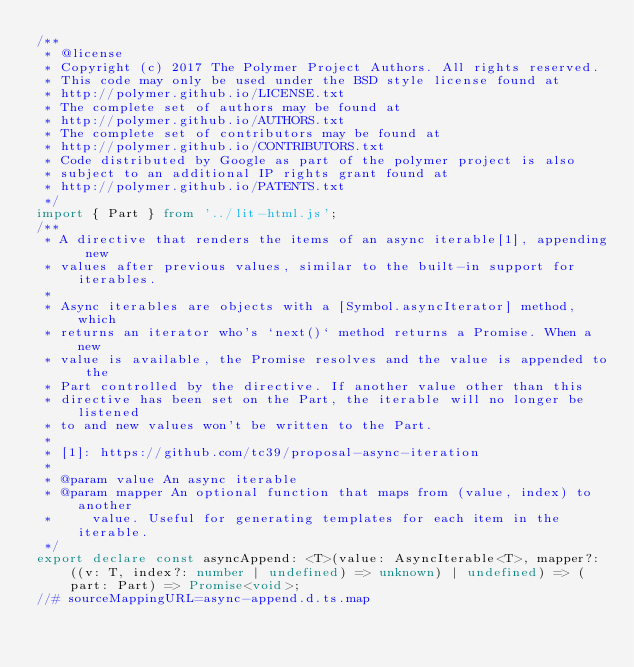<code> <loc_0><loc_0><loc_500><loc_500><_TypeScript_>/**
 * @license
 * Copyright (c) 2017 The Polymer Project Authors. All rights reserved.
 * This code may only be used under the BSD style license found at
 * http://polymer.github.io/LICENSE.txt
 * The complete set of authors may be found at
 * http://polymer.github.io/AUTHORS.txt
 * The complete set of contributors may be found at
 * http://polymer.github.io/CONTRIBUTORS.txt
 * Code distributed by Google as part of the polymer project is also
 * subject to an additional IP rights grant found at
 * http://polymer.github.io/PATENTS.txt
 */
import { Part } from '../lit-html.js';
/**
 * A directive that renders the items of an async iterable[1], appending new
 * values after previous values, similar to the built-in support for iterables.
 *
 * Async iterables are objects with a [Symbol.asyncIterator] method, which
 * returns an iterator who's `next()` method returns a Promise. When a new
 * value is available, the Promise resolves and the value is appended to the
 * Part controlled by the directive. If another value other than this
 * directive has been set on the Part, the iterable will no longer be listened
 * to and new values won't be written to the Part.
 *
 * [1]: https://github.com/tc39/proposal-async-iteration
 *
 * @param value An async iterable
 * @param mapper An optional function that maps from (value, index) to another
 *     value. Useful for generating templates for each item in the iterable.
 */
export declare const asyncAppend: <T>(value: AsyncIterable<T>, mapper?: ((v: T, index?: number | undefined) => unknown) | undefined) => (part: Part) => Promise<void>;
//# sourceMappingURL=async-append.d.ts.map
</code> 